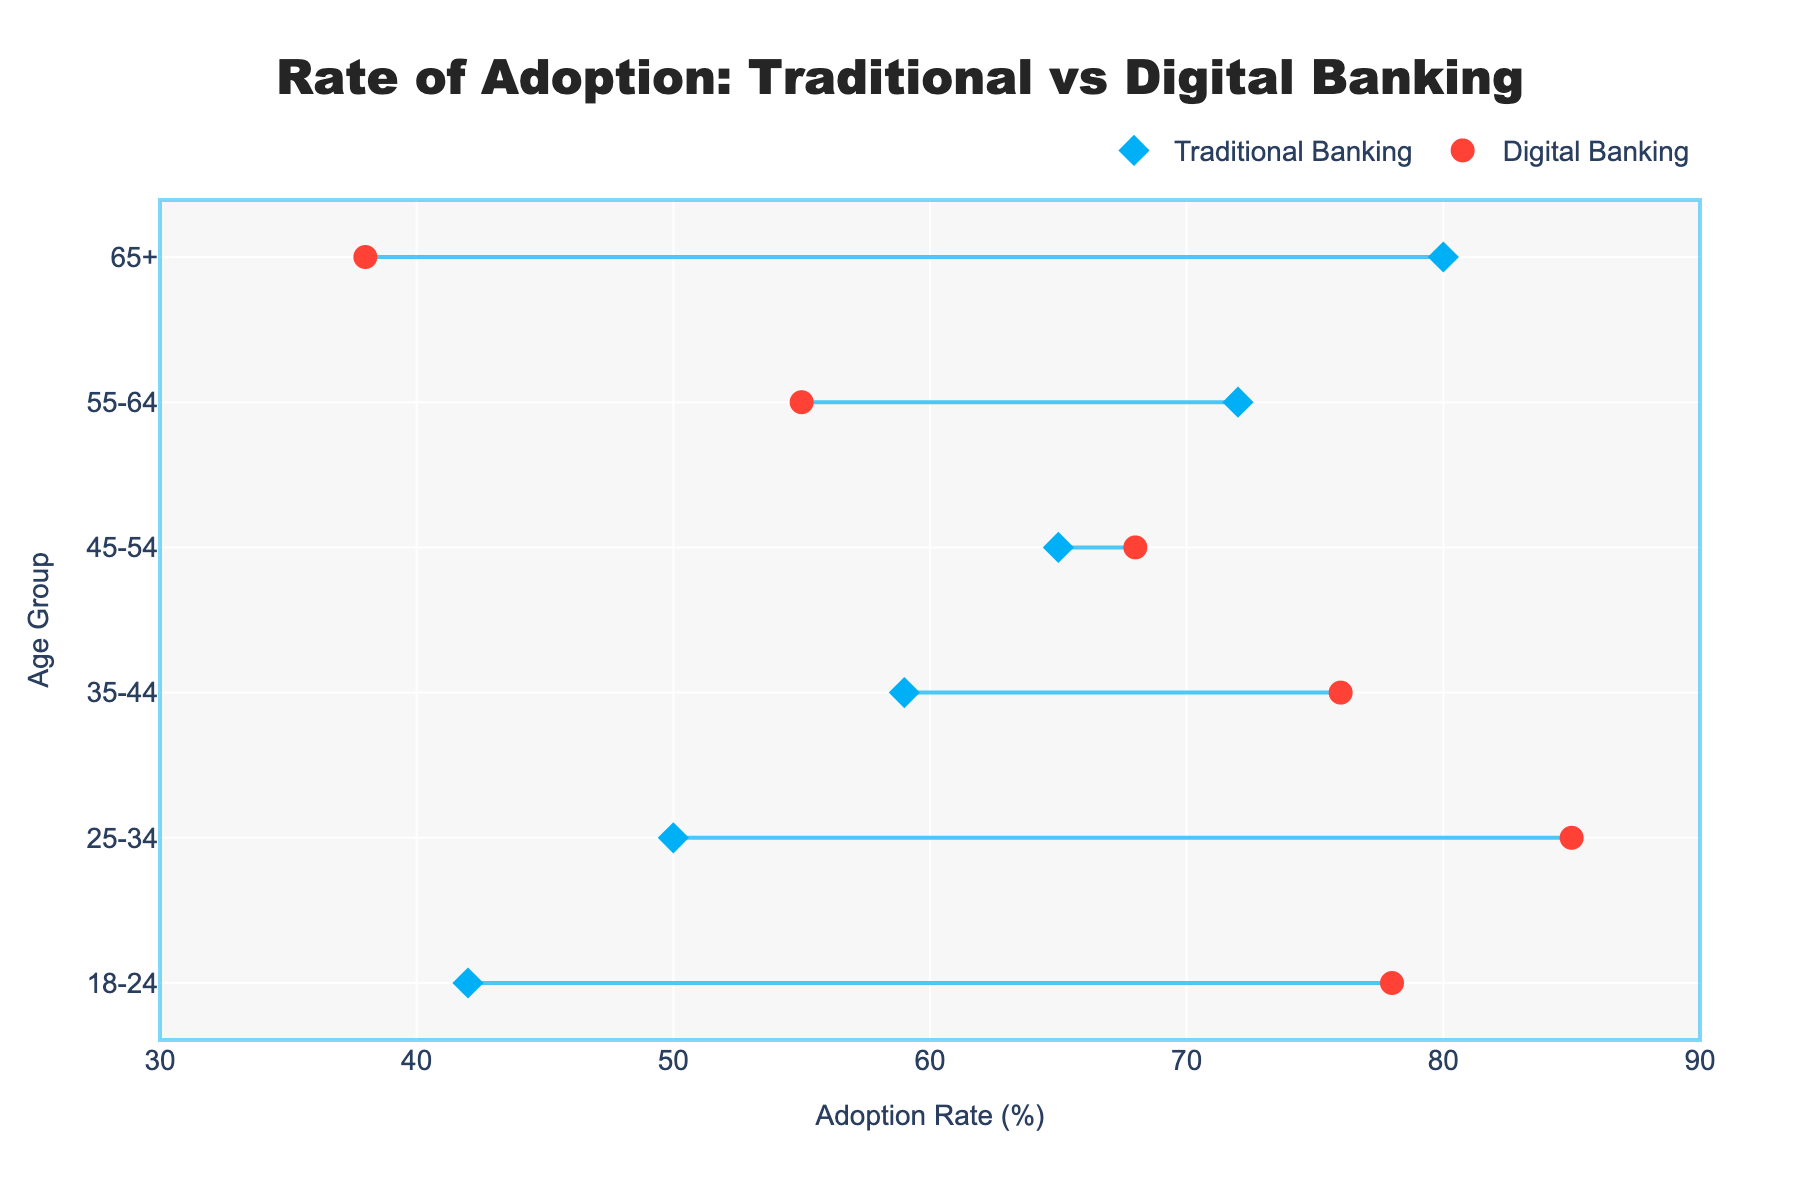what is the title of the figure? Look at the top center of the figure where the title is typically located. It reads: "Rate of Adoption: Traditional vs Digital Banking".
Answer: Rate of Adoption: Traditional vs Digital Banking Which age group has the highest adoption rate for digital banking? To find this, look at the markers for digital banking (red) and see which age group corresponds to the highest value. The highest value is at 85% for the age group 25-34.
Answer: 25-34 What is the difference in adoption rates for the age group 18-24? In the age group 18-24, the adoption rate for Traditional Banking is 42% and for Digital Banking is 78%. The difference is 78% - 42% = 36%.
Answer: 36 For which age group is the adoption of Traditional Banking higher than Digital Banking? Compare the traditional and digital banking values for each age group. The age groups where traditional banking has higher adoption rates are 45-54, 55-64, and 65+.
Answer: 45-54, 55-64, 65+ Which age group has the smallest difference between Traditional and Digital Banking adoption rates? Calculate the absolute differences between Traditional and Digital Banking adoption rates for each age group. The smallest difference is for the age group 45-54 (68% - 65% = 3%).
Answer: 45-54 How many age groups are shown in the figure? Count the distinct age groups listed on the y-axis. There are 6 age groups: 18-24, 25-34, 35-44, 45-54, 55-64, and 65+.
Answer: 6 Which age group shows a decline in adoption rate when transitioning from Traditional to Digital Banking? Look for an age group where the Digital Banking percentage is lower than the Traditional Banking percentage. This is true for the age groups 55-64 and 65+.
Answer: 55-64, 65+ By how much does the digital banking adoption rate exceed traditional banking for the age group 25-34? Compare the digital banking rate (85%) and the traditional banking rate (50%) for the age group 25-34. The difference is 85% - 50% = 35%.
Answer: 35 Is there an age group where the adoption rates for Traditional and Digital Banking are almost equal? Look for age groups where the markers for traditional and digital banking are very close. The age group 45-54 has almost equal adoption rates (68% for Digital and 65% for Traditional, a difference of 3%).
Answer: 45-54 Which age group has the highest adoption rate for Traditional Banking? Look at the markers for traditional banking (blue) and see which age group corresponds to the highest value. The highest value is 80% for the age group 65 and above.
Answer: 65+ 